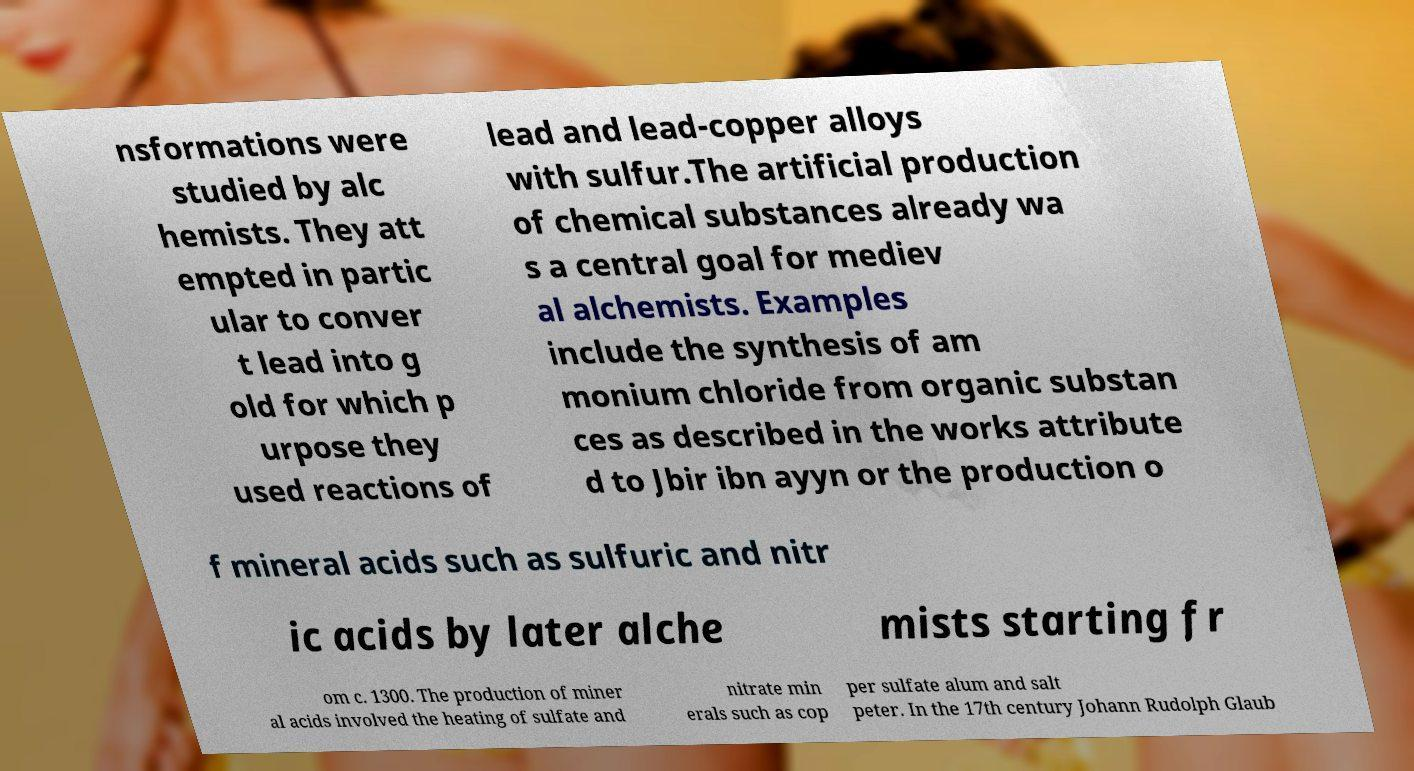For documentation purposes, I need the text within this image transcribed. Could you provide that? nsformations were studied by alc hemists. They att empted in partic ular to conver t lead into g old for which p urpose they used reactions of lead and lead-copper alloys with sulfur.The artificial production of chemical substances already wa s a central goal for mediev al alchemists. Examples include the synthesis of am monium chloride from organic substan ces as described in the works attribute d to Jbir ibn ayyn or the production o f mineral acids such as sulfuric and nitr ic acids by later alche mists starting fr om c. 1300. The production of miner al acids involved the heating of sulfate and nitrate min erals such as cop per sulfate alum and salt peter. In the 17th century Johann Rudolph Glaub 